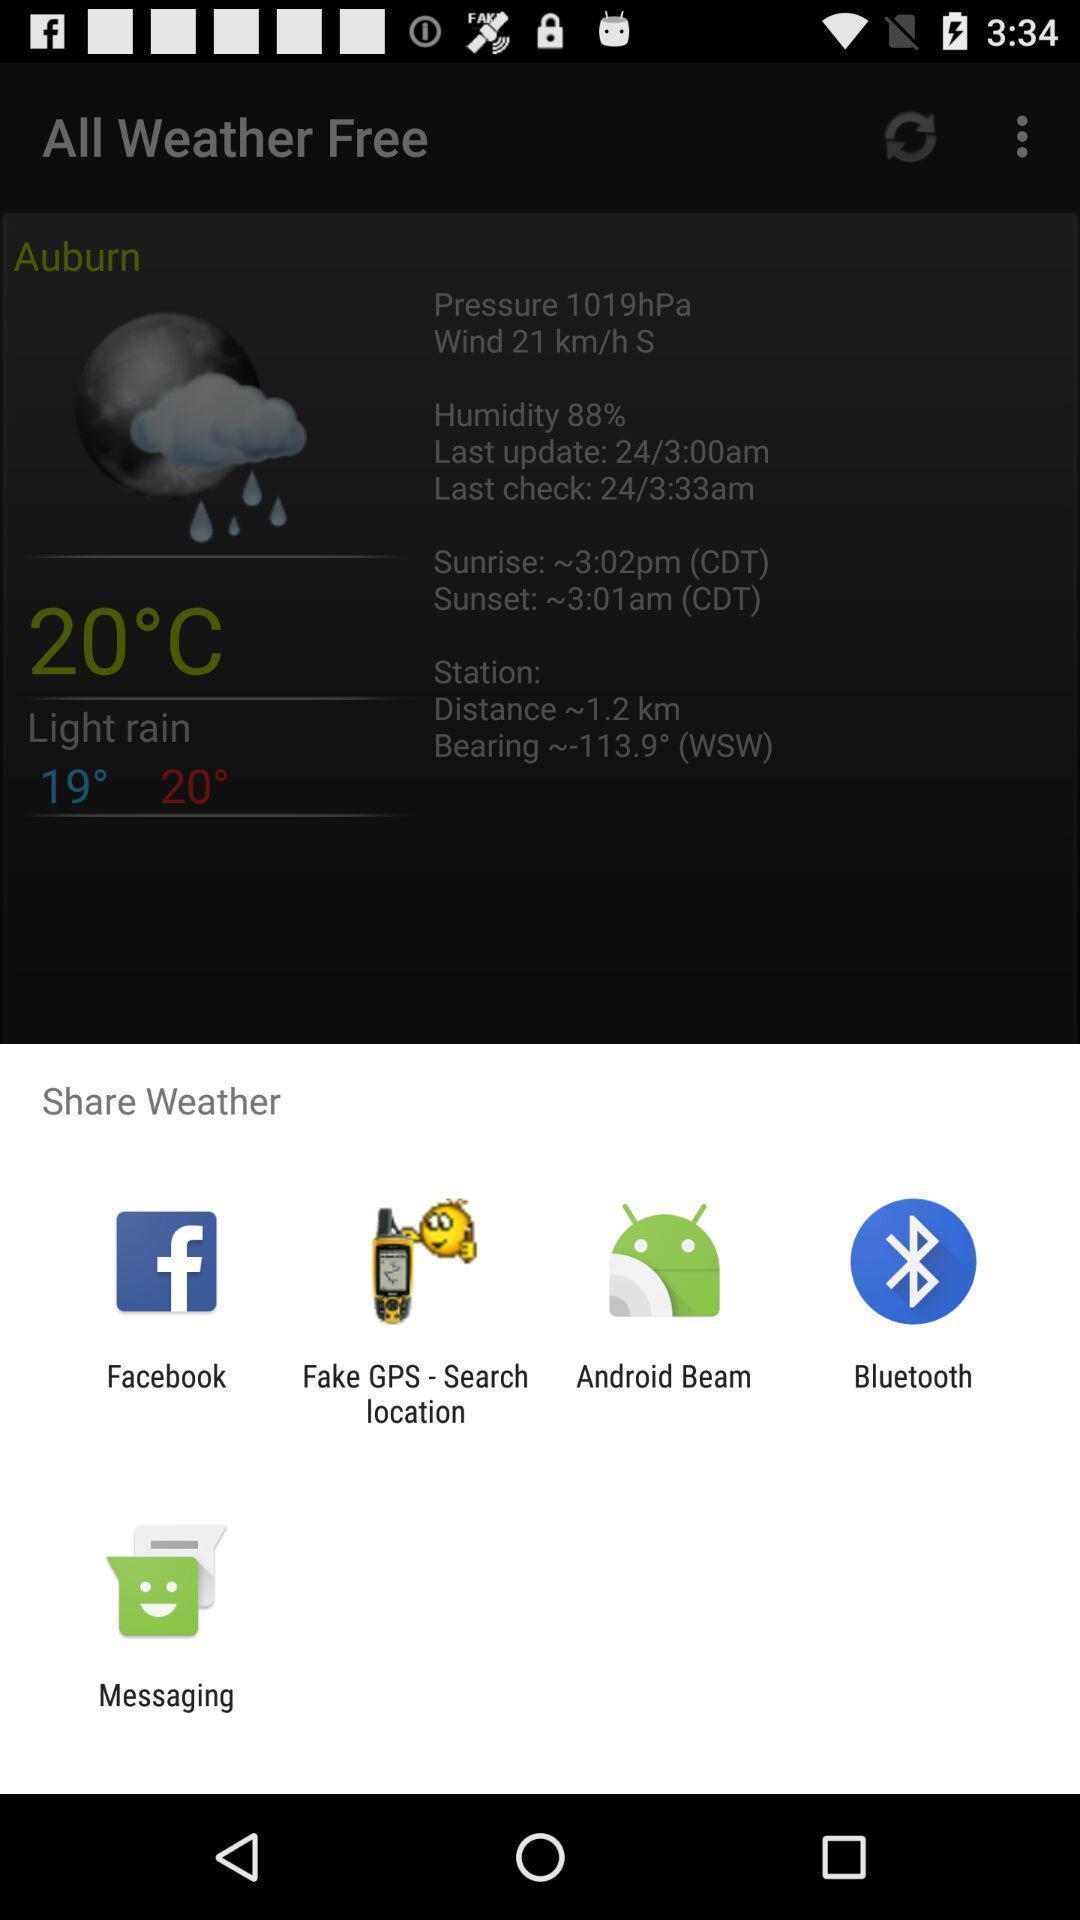Provide a textual representation of this image. Push up page showing app preference to share. 